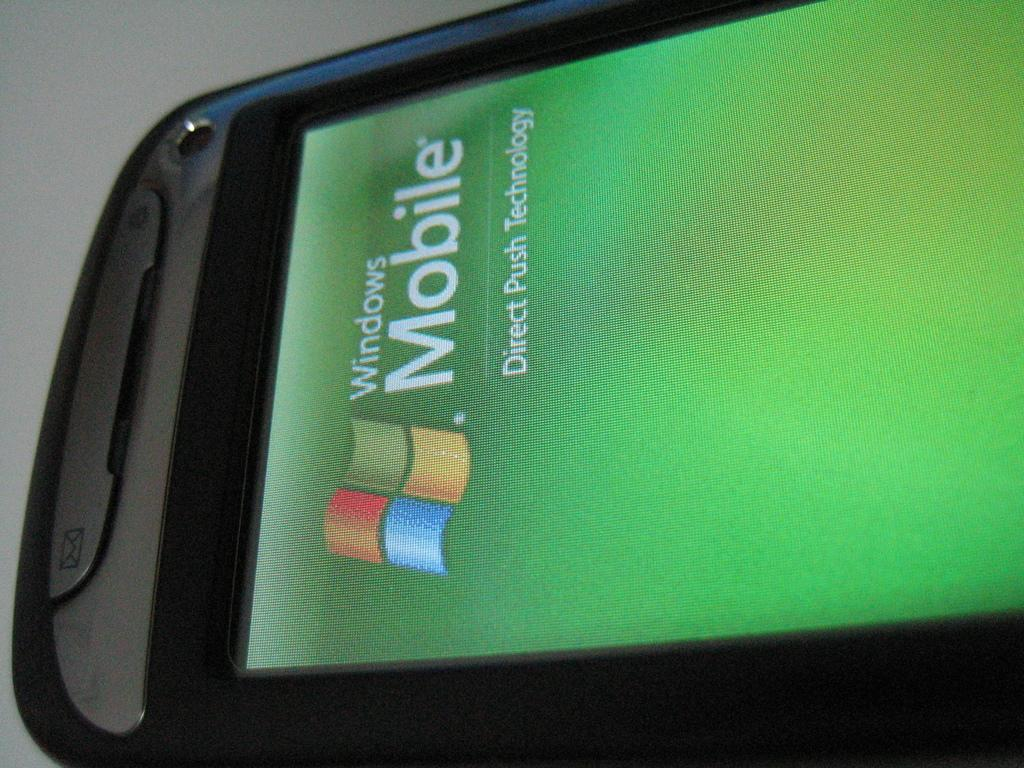Provide a one-sentence caption for the provided image. The program that is shown on the phone is part of the Windows Mobile technology. 